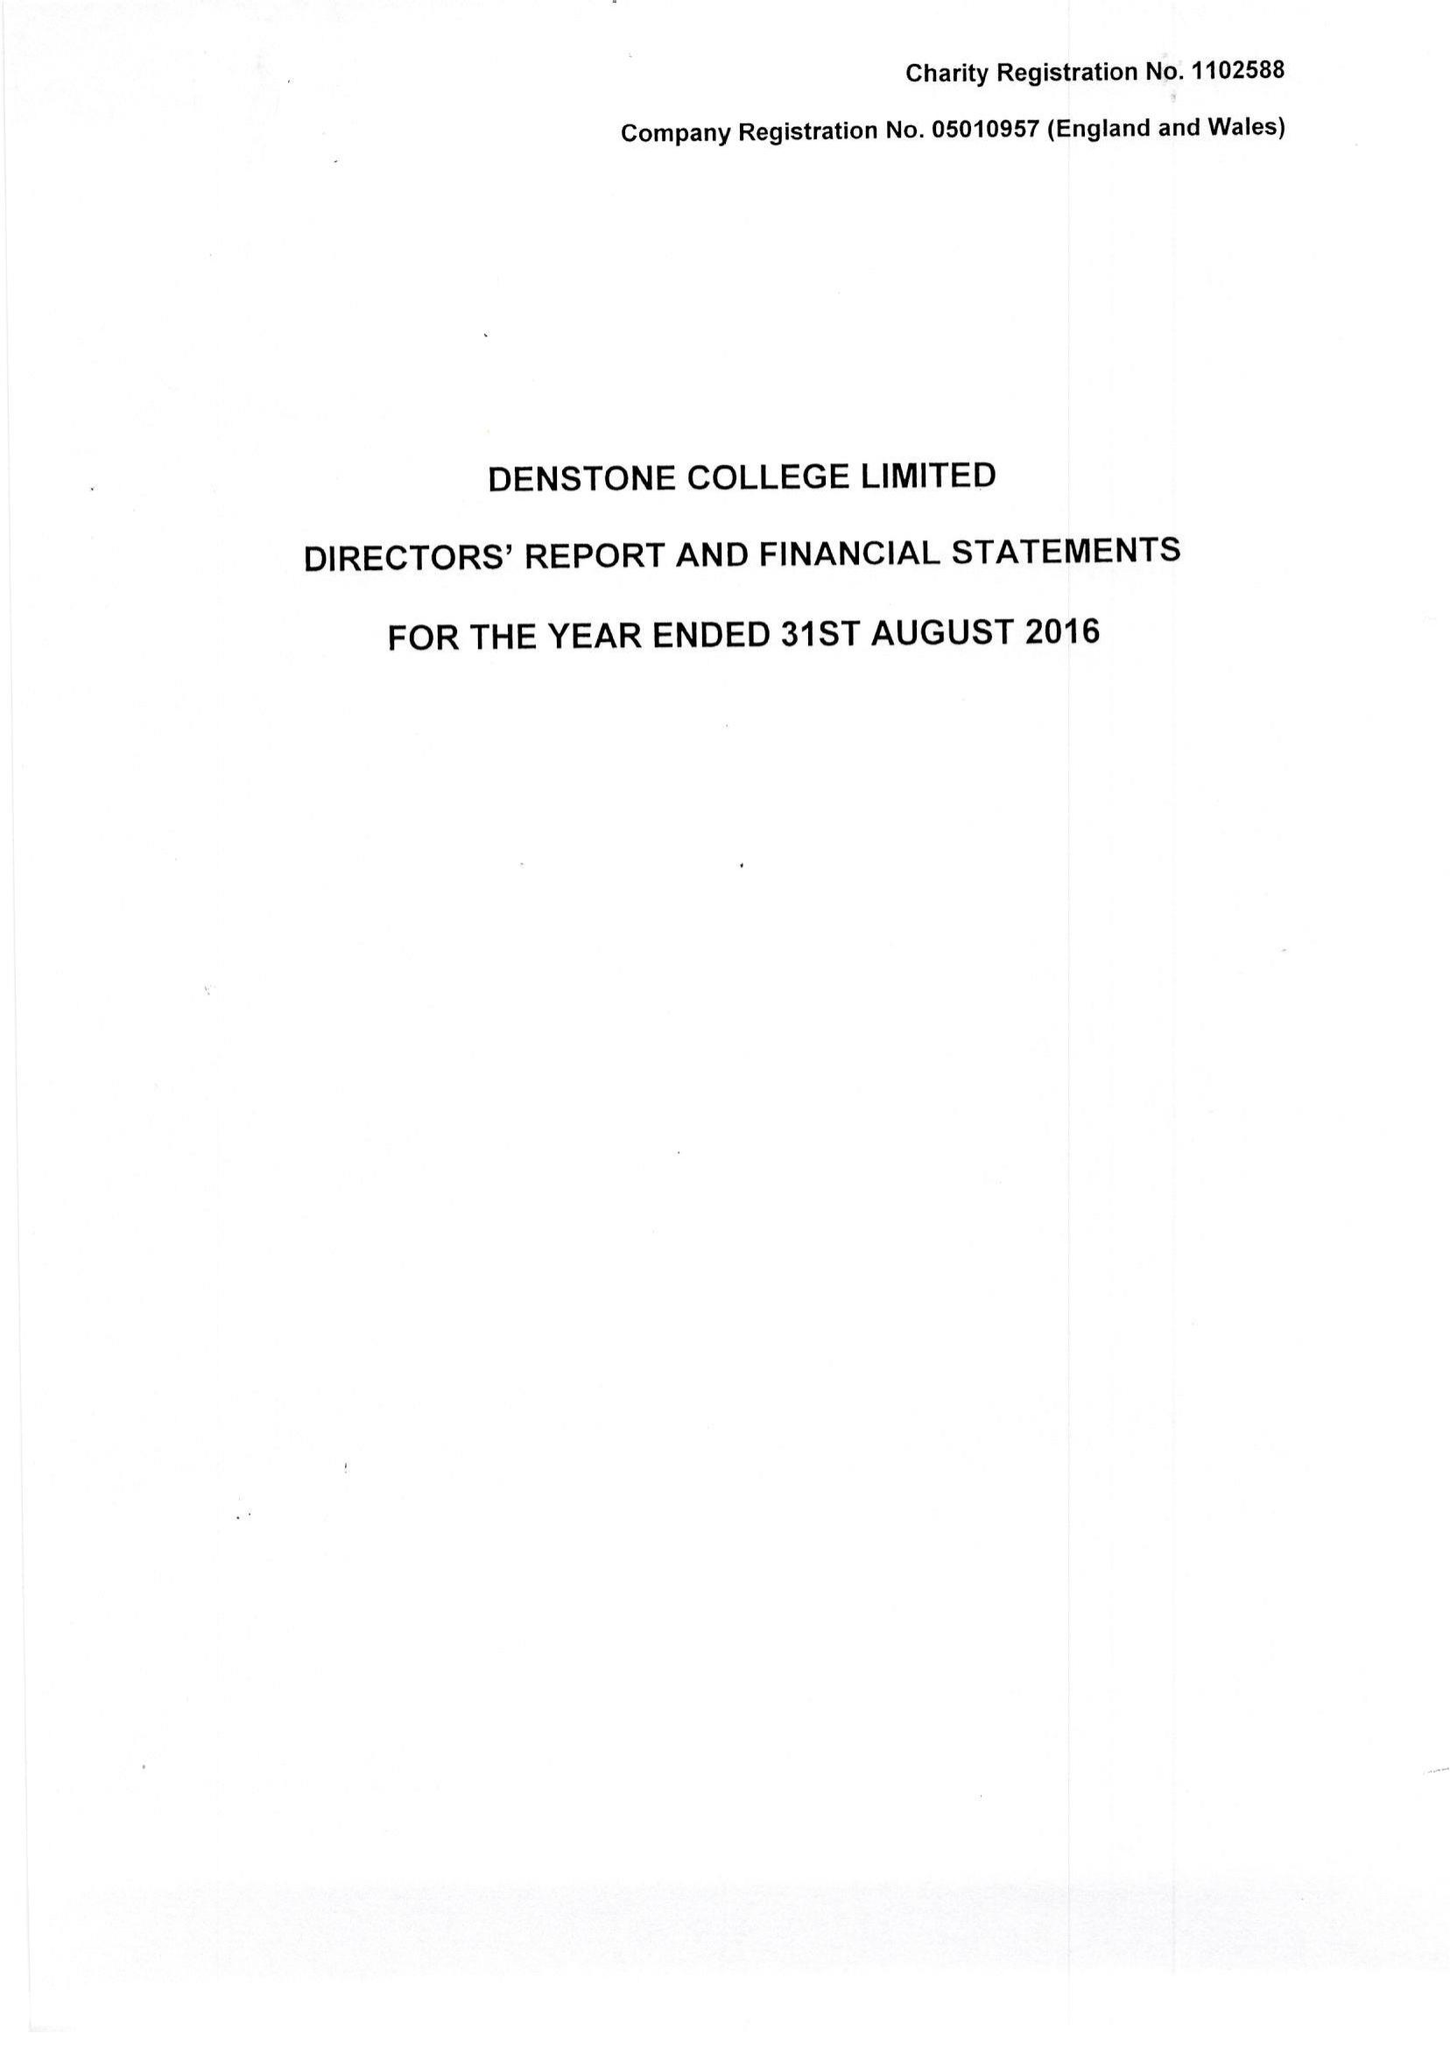What is the value for the address__street_line?
Answer the question using a single word or phrase. None 